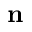<formula> <loc_0><loc_0><loc_500><loc_500>n</formula> 